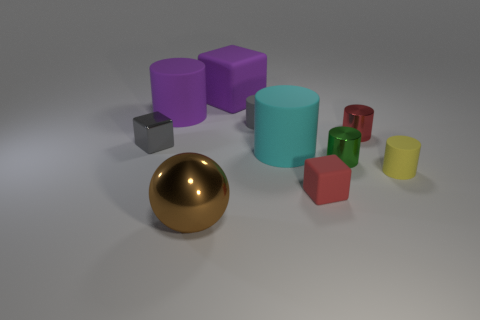There is a tiny matte object that is behind the tiny red shiny cylinder; does it have the same color as the metallic block?
Your response must be concise. Yes. Is the material of the tiny green object the same as the big cyan object?
Provide a short and direct response. No. What size is the thing on the left side of the large rubber cylinder behind the gray matte cylinder?
Ensure brevity in your answer.  Small. The red matte cube is what size?
Your answer should be very brief. Small. What number of metallic objects have the same color as the tiny rubber block?
Ensure brevity in your answer.  1. What number of tiny things are either cyan cylinders or yellow metallic cylinders?
Make the answer very short. 0. There is a big cube that is the same material as the big cyan object; what is its color?
Provide a short and direct response. Purple. Does the big purple rubber object that is on the right side of the large brown metallic thing have the same shape as the tiny red metallic object to the right of the cyan rubber cylinder?
Give a very brief answer. No. How many shiny things are tiny yellow objects or big cubes?
Your answer should be compact. 0. What material is the object that is the same color as the big block?
Give a very brief answer. Rubber. 